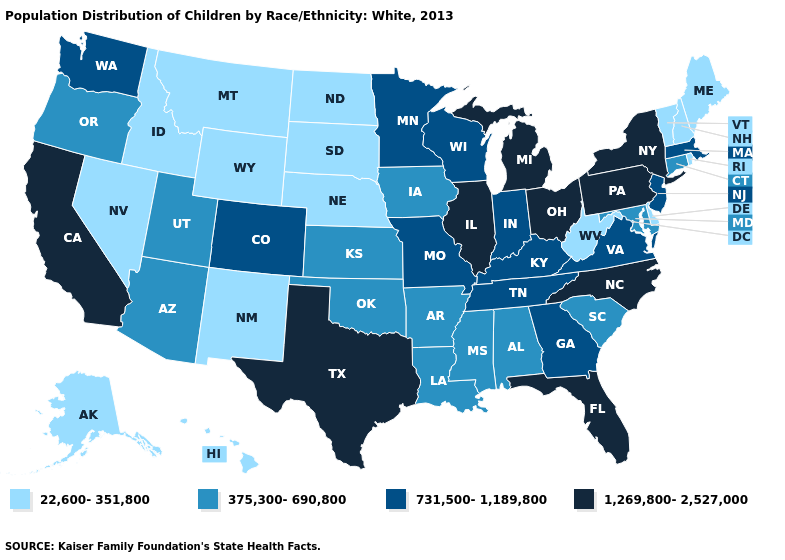What is the value of Maryland?
Quick response, please. 375,300-690,800. What is the value of Pennsylvania?
Keep it brief. 1,269,800-2,527,000. Among the states that border North Dakota , which have the lowest value?
Concise answer only. Montana, South Dakota. What is the highest value in the West ?
Concise answer only. 1,269,800-2,527,000. Name the states that have a value in the range 731,500-1,189,800?
Give a very brief answer. Colorado, Georgia, Indiana, Kentucky, Massachusetts, Minnesota, Missouri, New Jersey, Tennessee, Virginia, Washington, Wisconsin. Is the legend a continuous bar?
Be succinct. No. Does New Mexico have the same value as New Hampshire?
Give a very brief answer. Yes. Does Florida have the lowest value in the USA?
Give a very brief answer. No. Name the states that have a value in the range 22,600-351,800?
Keep it brief. Alaska, Delaware, Hawaii, Idaho, Maine, Montana, Nebraska, Nevada, New Hampshire, New Mexico, North Dakota, Rhode Island, South Dakota, Vermont, West Virginia, Wyoming. Is the legend a continuous bar?
Keep it brief. No. What is the value of Texas?
Be succinct. 1,269,800-2,527,000. Among the states that border Texas , which have the lowest value?
Write a very short answer. New Mexico. Name the states that have a value in the range 1,269,800-2,527,000?
Keep it brief. California, Florida, Illinois, Michigan, New York, North Carolina, Ohio, Pennsylvania, Texas. What is the value of Wisconsin?
Quick response, please. 731,500-1,189,800. What is the highest value in the USA?
Answer briefly. 1,269,800-2,527,000. 